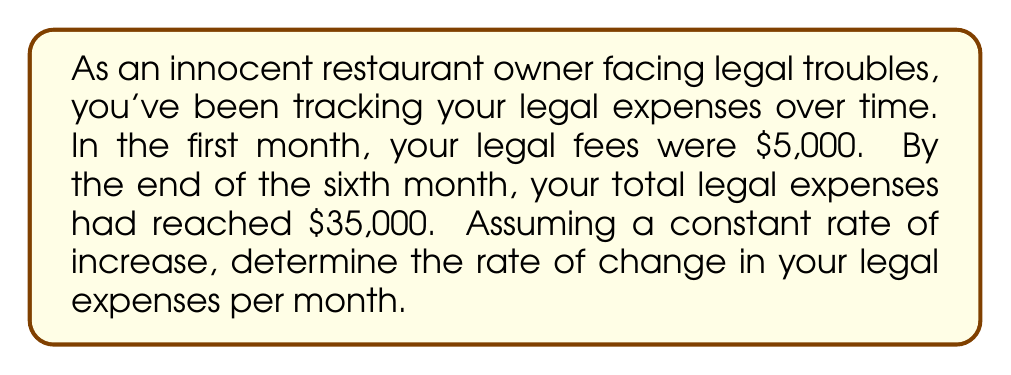Give your solution to this math problem. To solve this problem, we need to use the concept of rate of change, which is essentially the slope of a linear function. Let's approach this step-by-step:

1) First, let's identify our known values:
   - Initial expense (month 0): $5,000
   - Final expense (month 6): $35,000
   - Time period: 6 months

2) The rate of change formula is:
   
   $$\text{Rate of Change} = \frac{\text{Change in Y}}{\text{Change in X}} = \frac{\Delta Y}{\Delta X}$$

3) In this case:
   - $\Delta Y$ is the change in expenses: $35,000 - 5,000 = 30,000$
   - $\Delta X$ is the change in time: 6 months

4) Let's plug these values into our formula:

   $$\text{Rate of Change} = \frac{30,000}{6}$$

5) Simplify:

   $$\text{Rate of Change} = 5,000$$

This means the legal expenses are increasing by $5,000 per month.
Answer: $5,000 per month 